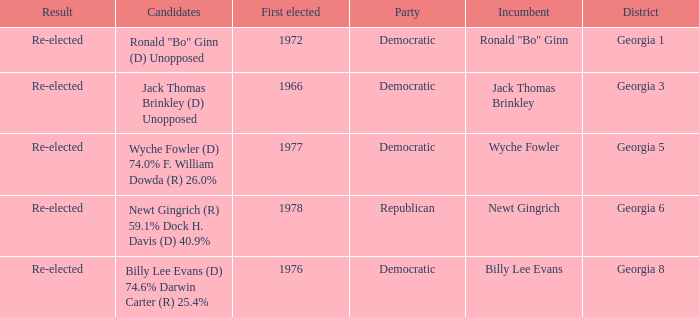How many incumbents were for district georgia 6? 1.0. 